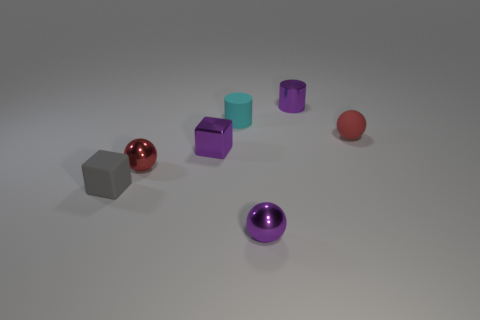Subtract all small red spheres. How many spheres are left? 1 Subtract all purple balls. How many balls are left? 2 Subtract 2 blocks. How many blocks are left? 0 Add 3 red rubber objects. How many objects exist? 10 Subtract 0 blue cylinders. How many objects are left? 7 Subtract all cylinders. How many objects are left? 5 Subtract all cyan cylinders. Subtract all yellow cubes. How many cylinders are left? 1 Subtract all blue cylinders. How many purple spheres are left? 1 Subtract all tiny metal balls. Subtract all big red cylinders. How many objects are left? 5 Add 2 red metal things. How many red metal things are left? 3 